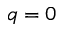<formula> <loc_0><loc_0><loc_500><loc_500>q = 0</formula> 